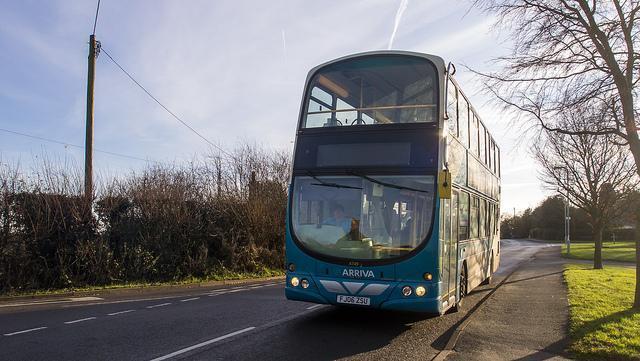How is this bus different from traditional US buses?
Choose the correct response and explain in the format: 'Answer: answer
Rationale: rationale.'
Options: Electric, double wide, windowless, double-decker. Answer: double-decker.
Rationale: This bus has two levels visible through the front windshield. most buses operating in the us have one level so this would be distinct because of the double deck. 